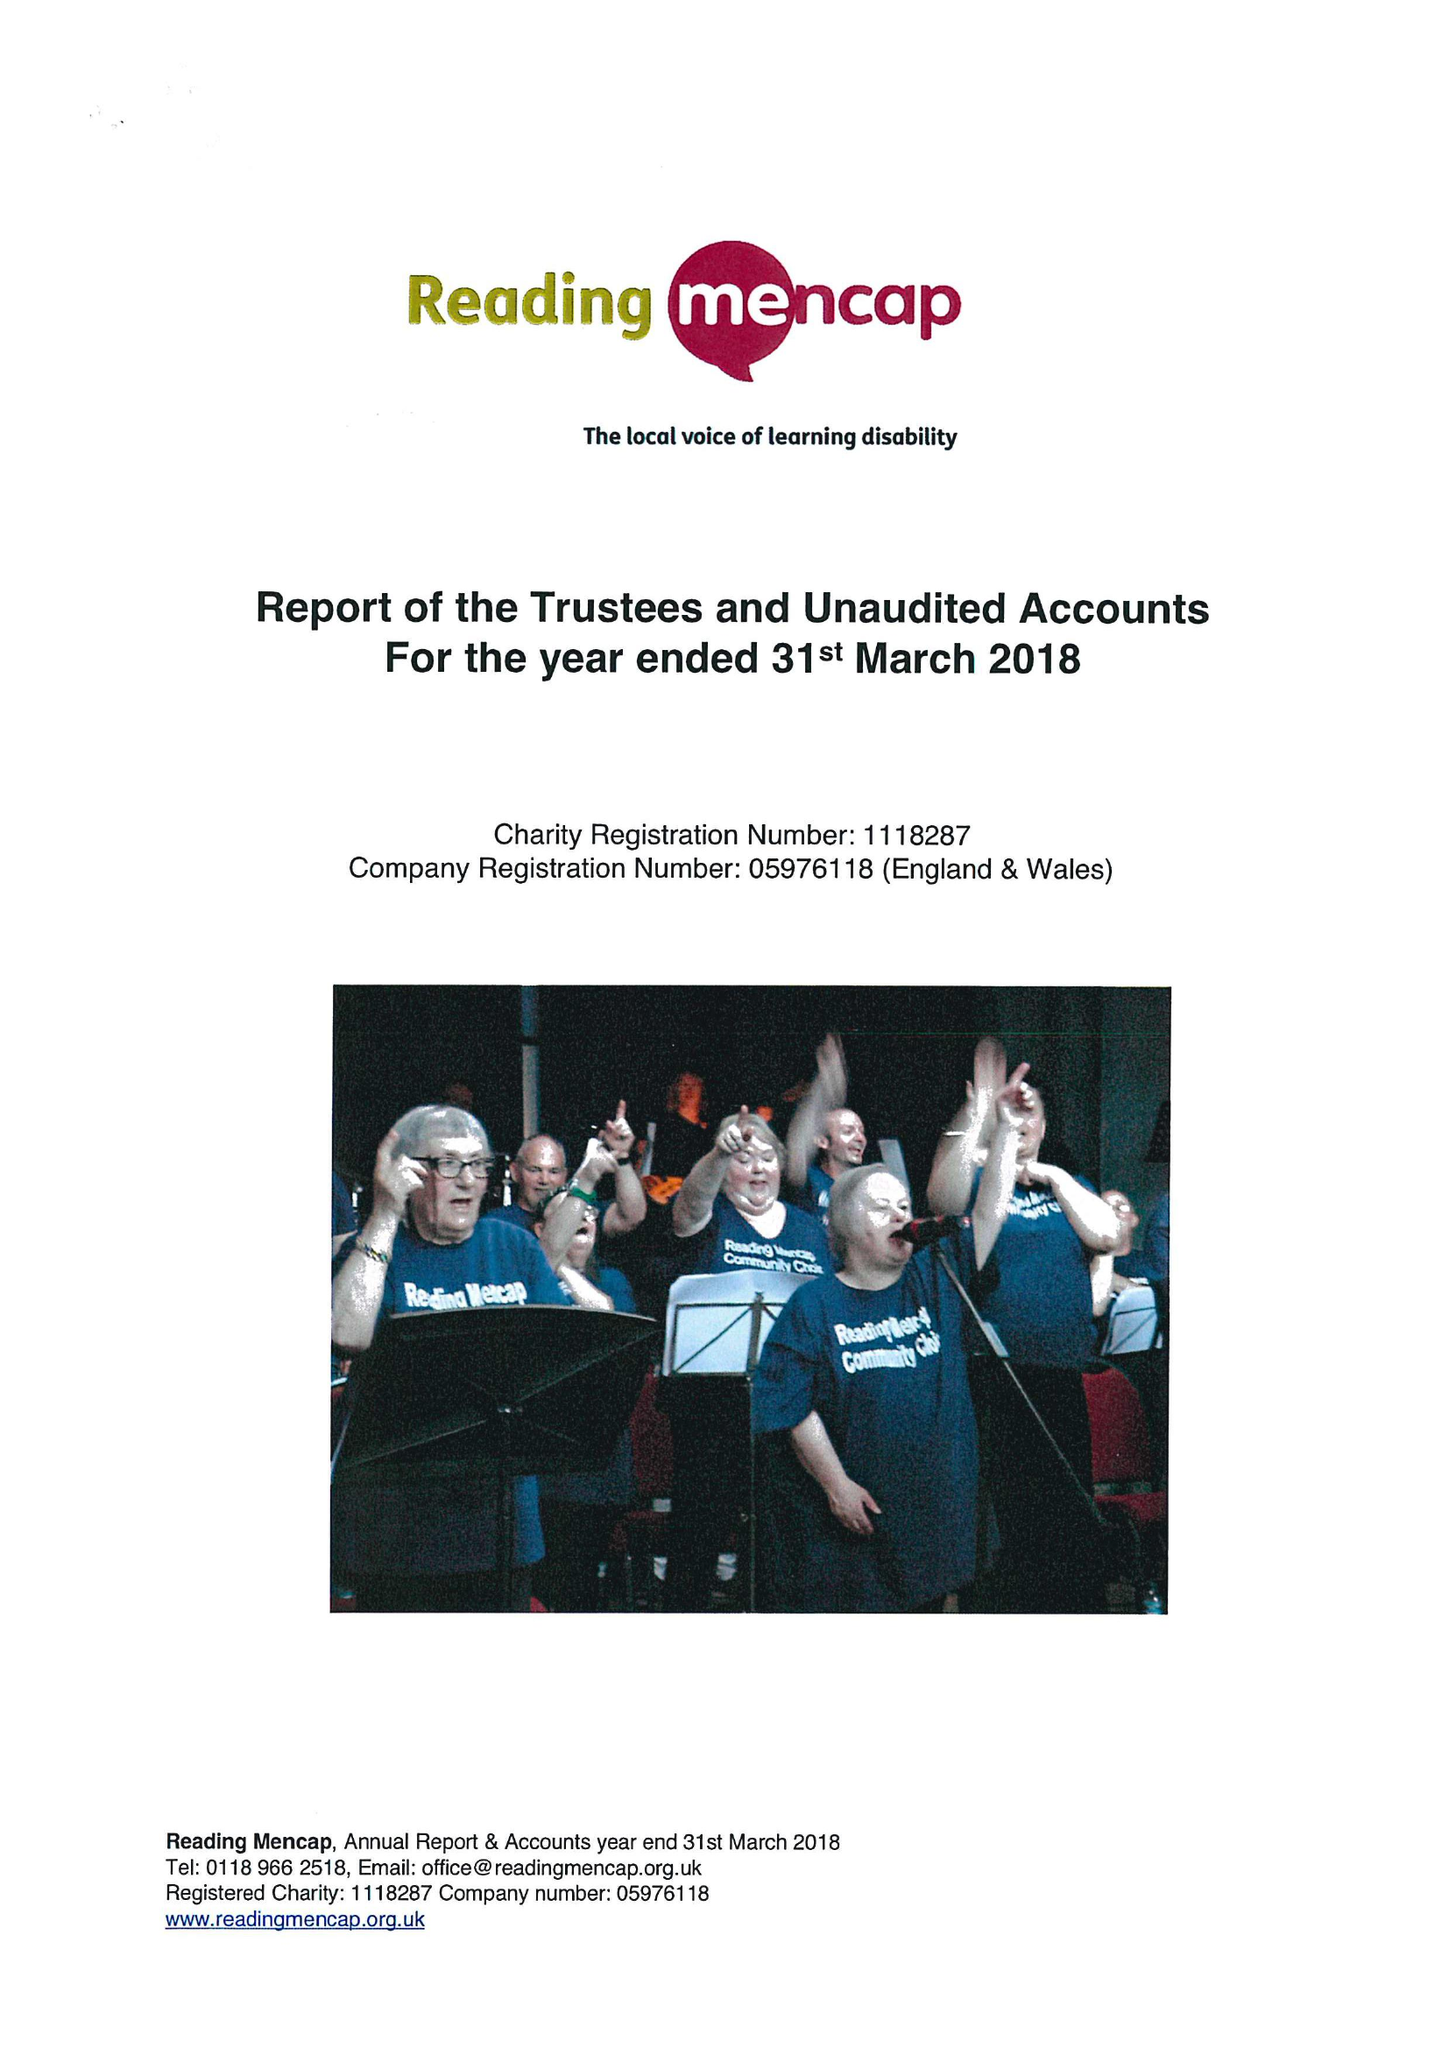What is the value for the address__street_line?
Answer the question using a single word or phrase. 21 ALEXANDRA ROAD 